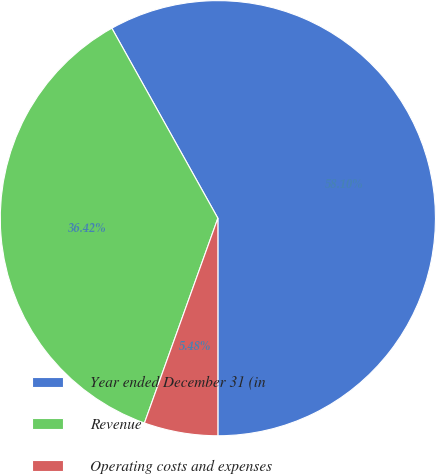<chart> <loc_0><loc_0><loc_500><loc_500><pie_chart><fcel>Year ended December 31 (in<fcel>Revenue<fcel>Operating costs and expenses<nl><fcel>58.1%<fcel>36.42%<fcel>5.48%<nl></chart> 